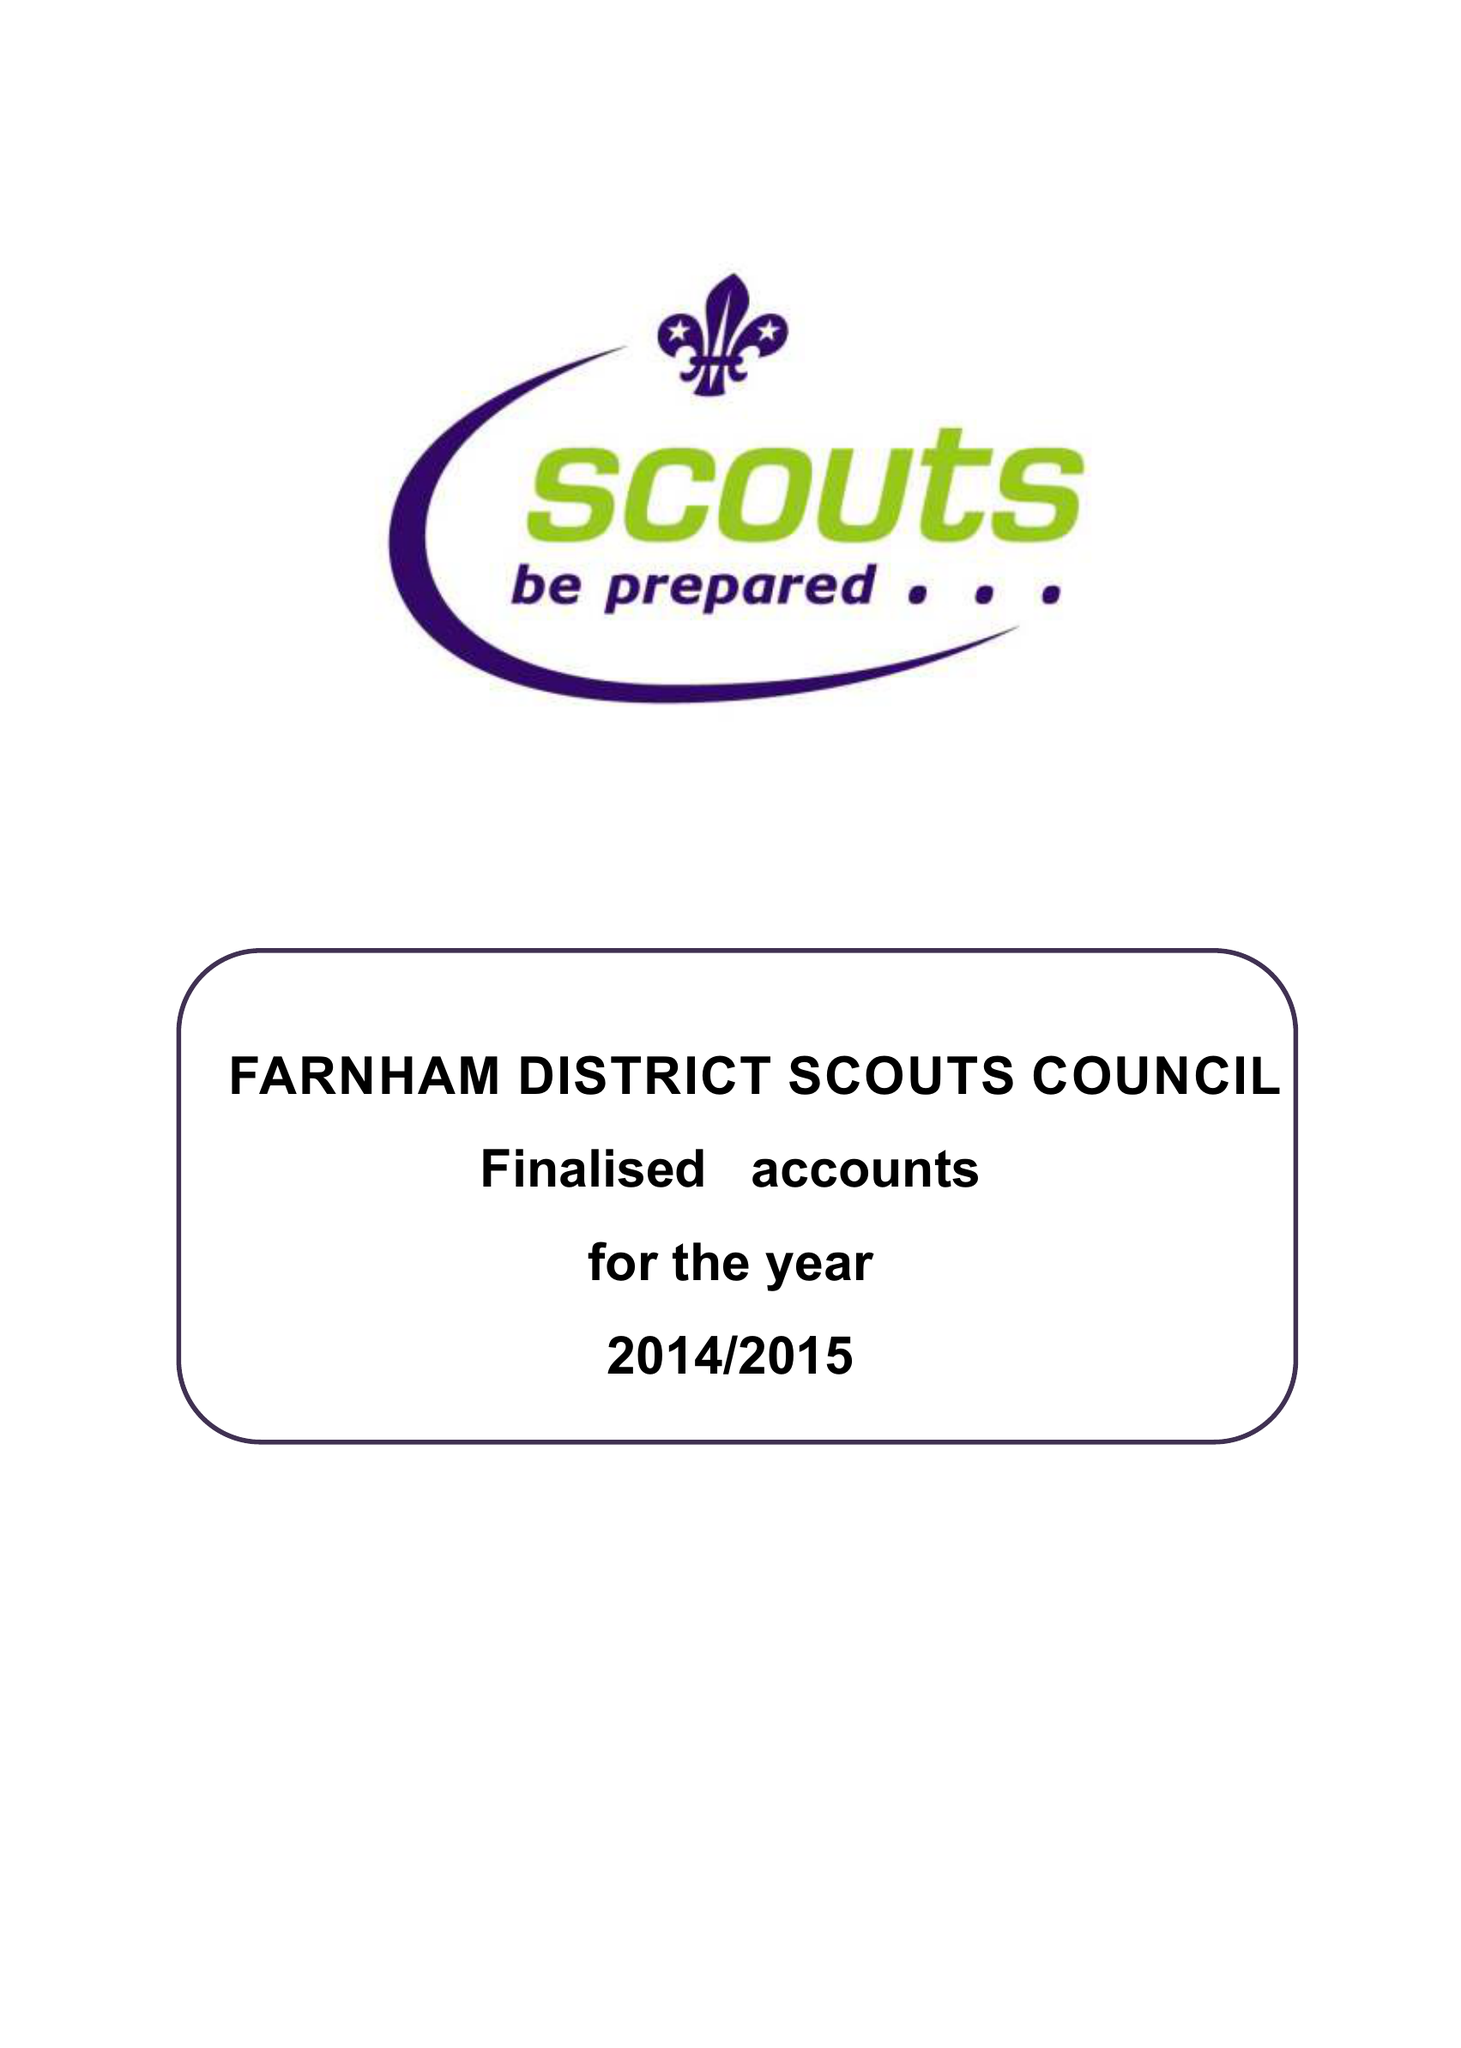What is the value for the charity_name?
Answer the question using a single word or phrase. Farnham District Scout Council 